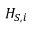<formula> <loc_0><loc_0><loc_500><loc_500>H _ { S , i }</formula> 